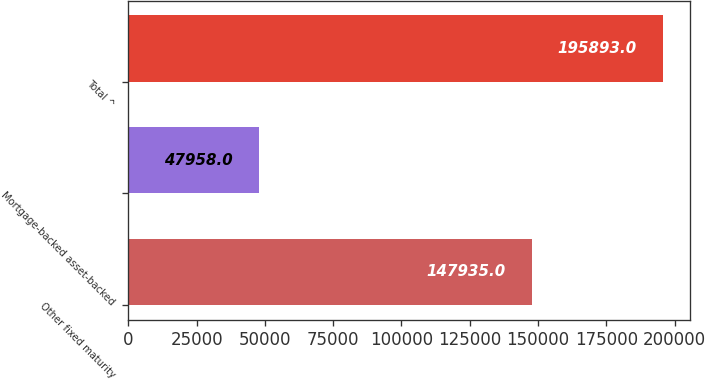Convert chart to OTSL. <chart><loc_0><loc_0><loc_500><loc_500><bar_chart><fcel>Other fixed maturity<fcel>Mortgage-backed asset-backed<fcel>Total ^<nl><fcel>147935<fcel>47958<fcel>195893<nl></chart> 